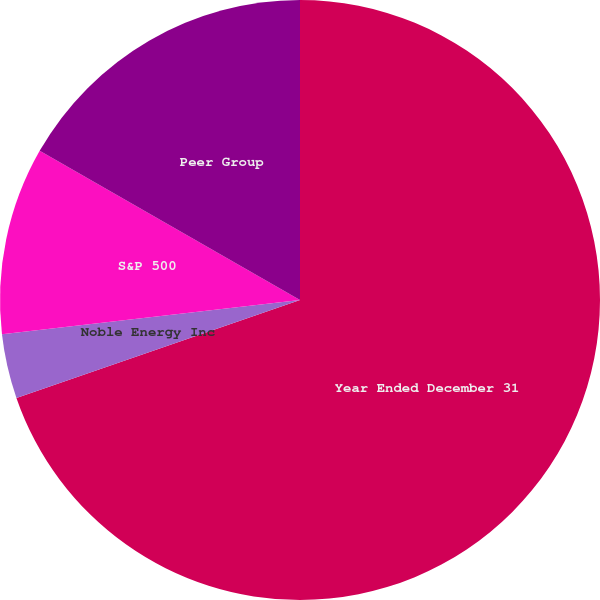<chart> <loc_0><loc_0><loc_500><loc_500><pie_chart><fcel>Year Ended December 31<fcel>Noble Energy Inc<fcel>S&P 500<fcel>Peer Group<nl><fcel>69.71%<fcel>3.47%<fcel>10.1%<fcel>16.72%<nl></chart> 